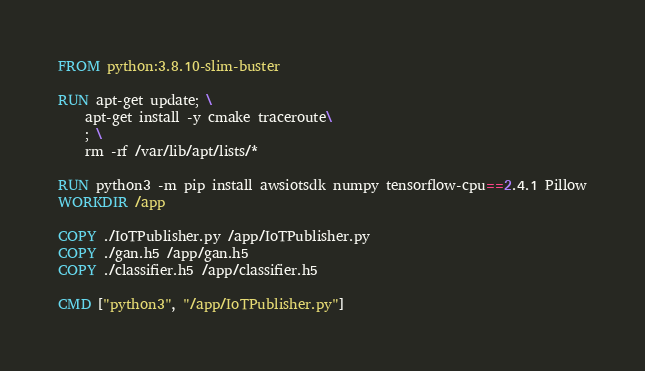<code> <loc_0><loc_0><loc_500><loc_500><_Dockerfile_>FROM python:3.8.10-slim-buster

RUN apt-get update; \
    apt-get install -y cmake traceroute\
    ; \
    rm -rf /var/lib/apt/lists/*

RUN python3 -m pip install awsiotsdk numpy tensorflow-cpu==2.4.1 Pillow
WORKDIR /app

COPY ./IoTPublisher.py /app/IoTPublisher.py
COPY ./gan.h5 /app/gan.h5
COPY ./classifier.h5 /app/classifier.h5

CMD ["python3", "/app/IoTPublisher.py"]
</code> 